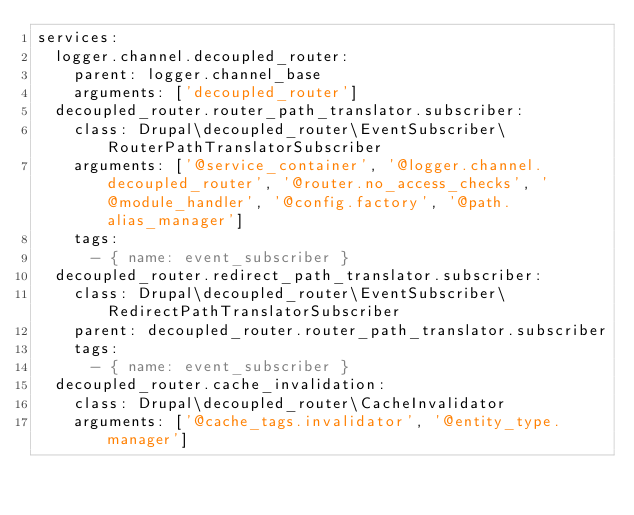Convert code to text. <code><loc_0><loc_0><loc_500><loc_500><_YAML_>services:
  logger.channel.decoupled_router:
    parent: logger.channel_base
    arguments: ['decoupled_router']
  decoupled_router.router_path_translator.subscriber:
    class: Drupal\decoupled_router\EventSubscriber\RouterPathTranslatorSubscriber
    arguments: ['@service_container', '@logger.channel.decoupled_router', '@router.no_access_checks', '@module_handler', '@config.factory', '@path.alias_manager']
    tags:
      - { name: event_subscriber }
  decoupled_router.redirect_path_translator.subscriber:
    class: Drupal\decoupled_router\EventSubscriber\RedirectPathTranslatorSubscriber
    parent: decoupled_router.router_path_translator.subscriber
    tags:
      - { name: event_subscriber }
  decoupled_router.cache_invalidation:
    class: Drupal\decoupled_router\CacheInvalidator
    arguments: ['@cache_tags.invalidator', '@entity_type.manager']
</code> 